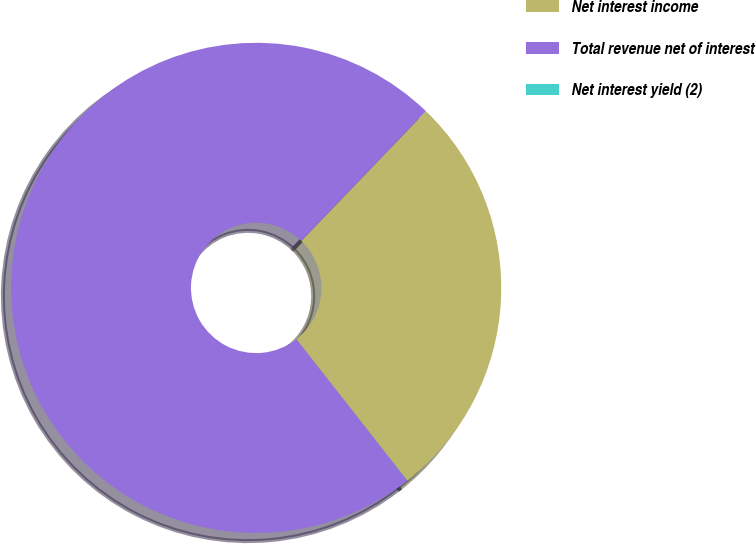Convert chart to OTSL. <chart><loc_0><loc_0><loc_500><loc_500><pie_chart><fcel>Net interest income<fcel>Total revenue net of interest<fcel>Net interest yield (2)<nl><fcel>27.23%<fcel>72.77%<fcel>0.01%<nl></chart> 